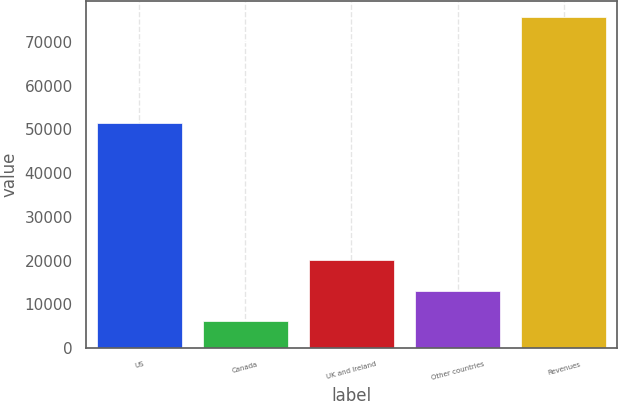Convert chart to OTSL. <chart><loc_0><loc_0><loc_500><loc_500><bar_chart><fcel>US<fcel>Canada<fcel>UK and Ireland<fcel>Other countries<fcel>Revenues<nl><fcel>51479<fcel>6115<fcel>20023.8<fcel>13069.4<fcel>75659<nl></chart> 